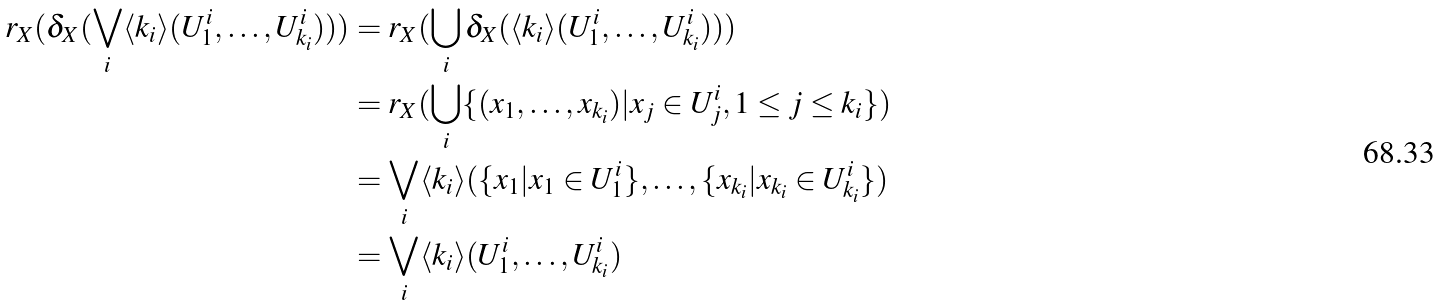<formula> <loc_0><loc_0><loc_500><loc_500>r _ { X } ( \delta _ { X } ( \bigvee _ { i } \langle k _ { i } \rangle ( U ^ { i } _ { 1 } , \dots , U ^ { i } _ { k _ { i } } ) ) ) & = r _ { X } ( \bigcup _ { i } \delta _ { X } ( \langle k _ { i } \rangle ( U ^ { i } _ { 1 } , \dots , U ^ { i } _ { k _ { i } } ) ) ) \\ & = r _ { X } ( \bigcup _ { i } \{ ( x _ { 1 } , \dots , x _ { k _ { i } } ) | x _ { j } \in U ^ { i } _ { j } , 1 \leq j \leq k _ { i } \} ) \\ & = \bigvee _ { i } \langle k _ { i } \rangle ( \{ x _ { 1 } | x _ { 1 } \in U _ { 1 } ^ { i } \} , \dots , \{ x _ { k _ { i } } | x _ { k _ { i } } \in U _ { k _ { i } } ^ { i } \} ) \\ & = \bigvee _ { i } \langle k _ { i } \rangle ( U ^ { i } _ { 1 } , \dots , U ^ { i } _ { k _ { i } } )</formula> 